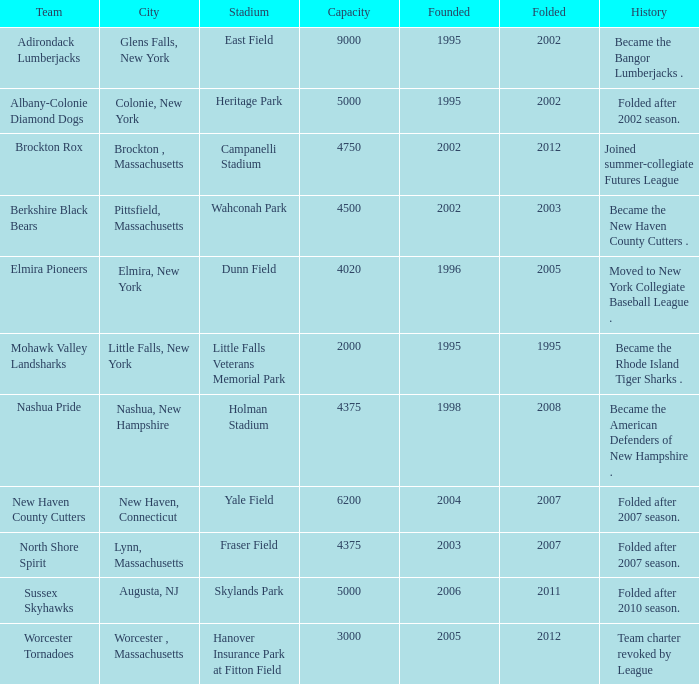What is the furthest inception year of the worcester tornadoes? 2005.0. 